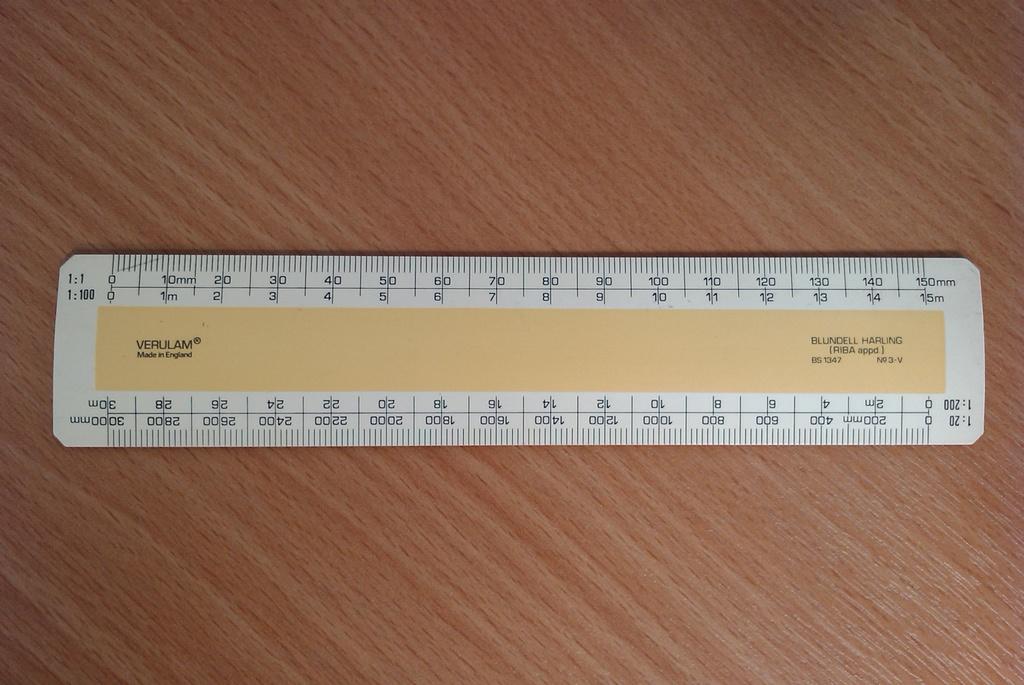Does verulam make rulers?
Ensure brevity in your answer.  Yes. Where is verulam from?
Ensure brevity in your answer.  England. 